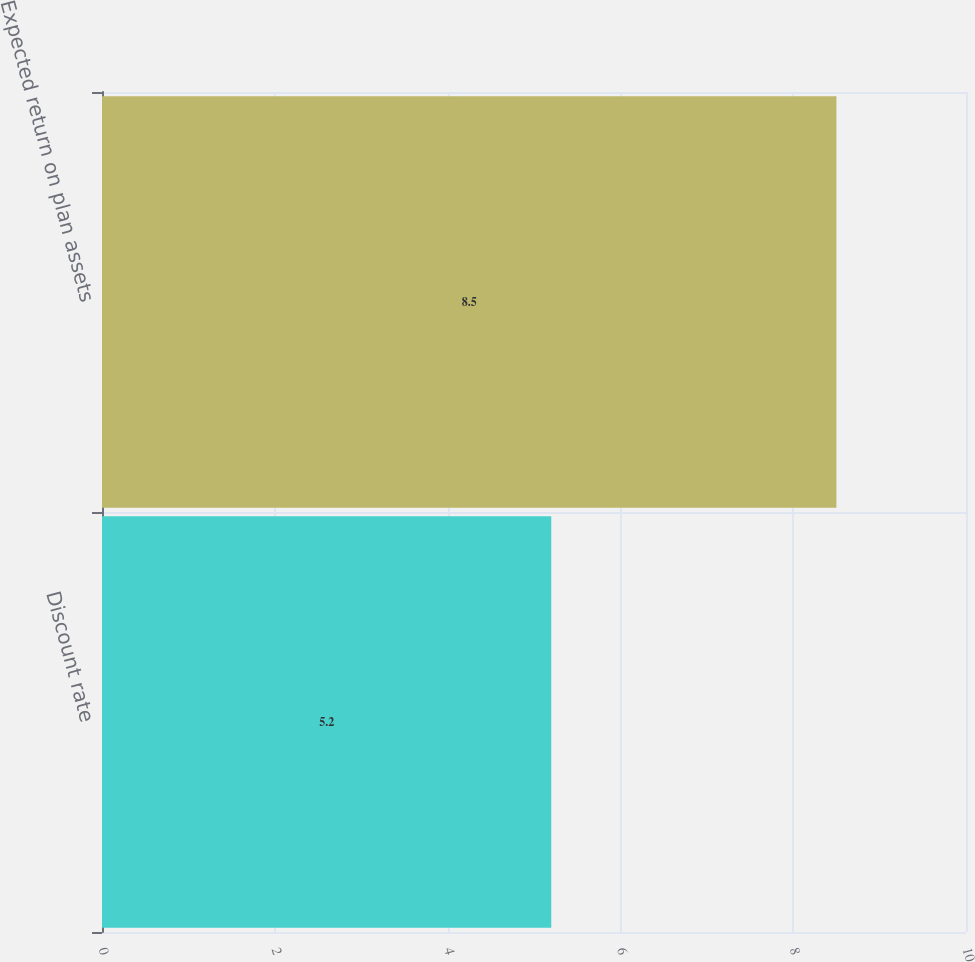Convert chart. <chart><loc_0><loc_0><loc_500><loc_500><bar_chart><fcel>Discount rate<fcel>Expected return on plan assets<nl><fcel>5.2<fcel>8.5<nl></chart> 